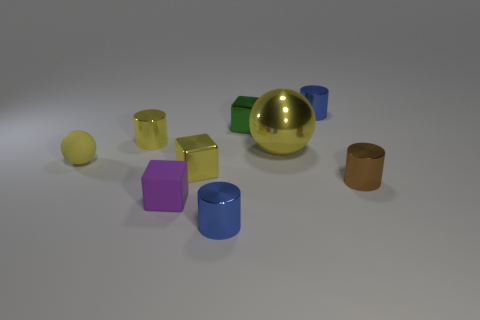Do the rubber thing that is behind the tiny rubber block and the small blue shiny object that is on the right side of the large ball have the same shape? no 